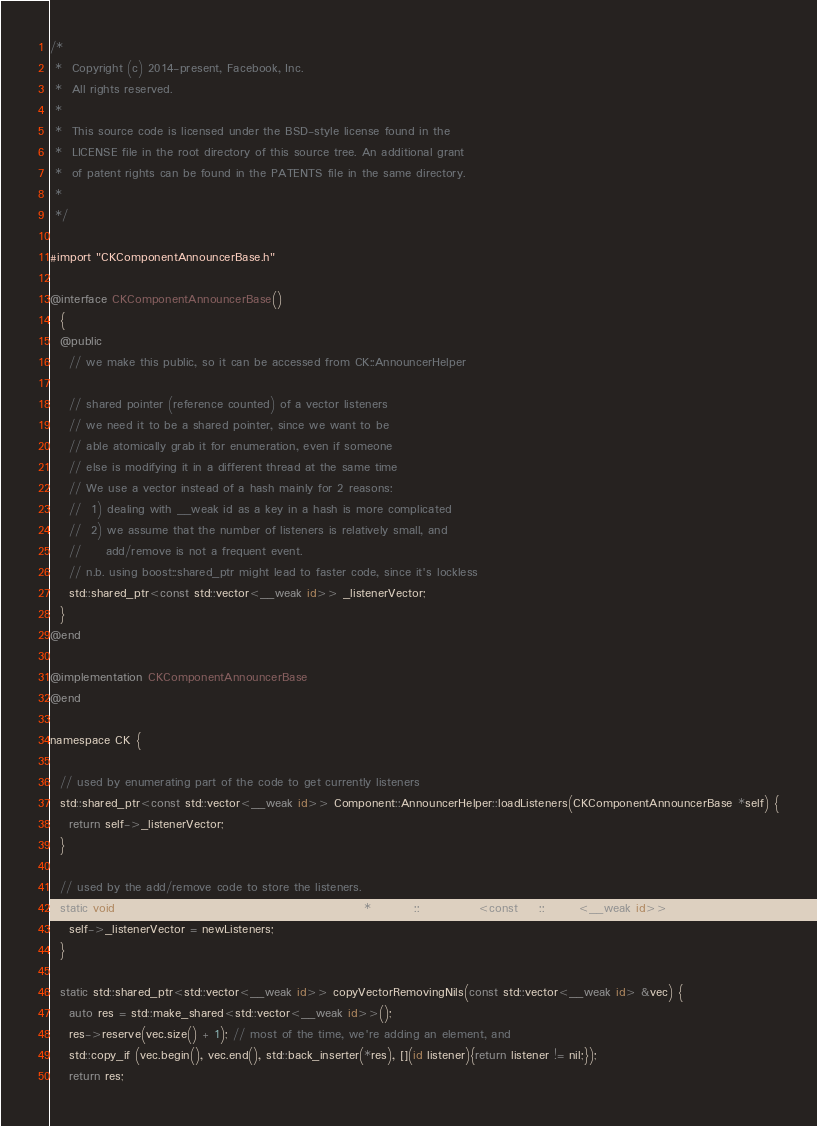<code> <loc_0><loc_0><loc_500><loc_500><_ObjectiveC_>/*
 *  Copyright (c) 2014-present, Facebook, Inc.
 *  All rights reserved.
 *
 *  This source code is licensed under the BSD-style license found in the
 *  LICENSE file in the root directory of this source tree. An additional grant 
 *  of patent rights can be found in the PATENTS file in the same directory.
 *
 */

#import "CKComponentAnnouncerBase.h"

@interface CKComponentAnnouncerBase()
  {
  @public
    // we make this public, so it can be accessed from CK::AnnouncerHelper
    
    // shared pointer (reference counted) of a vector listeners
    // we need it to be a shared pointer, since we want to be
    // able atomically grab it for enumeration, even if someone
    // else is modifying it in a different thread at the same time
    // We use a vector instead of a hash mainly for 2 reasons:
    //  1) dealing with __weak id as a key in a hash is more complicated
    //  2) we assume that the number of listeners is relatively small, and
    //     add/remove is not a frequent event.
    // n.b. using boost::shared_ptr might lead to faster code, since it's lockless
    std::shared_ptr<const std::vector<__weak id>> _listenerVector;
  }
@end

@implementation CKComponentAnnouncerBase
@end

namespace CK {

  // used by enumerating part of the code to get currently listeners
  std::shared_ptr<const std::vector<__weak id>> Component::AnnouncerHelper::loadListeners(CKComponentAnnouncerBase *self) {
    return self->_listenerVector;
  }

  // used by the add/remove code to store the listeners.
  static void storeListeners(CKComponentAnnouncerBase *self, std::shared_ptr<const std::vector<__weak id>> newListeners) {
    self->_listenerVector = newListeners;
  }

  static std::shared_ptr<std::vector<__weak id>> copyVectorRemovingNils(const std::vector<__weak id> &vec) {
    auto res = std::make_shared<std::vector<__weak id>>();
    res->reserve(vec.size() + 1); // most of the time, we're adding an element, and
    std::copy_if (vec.begin(), vec.end(), std::back_inserter(*res), [](id listener){return listener != nil;});
    return res;</code> 